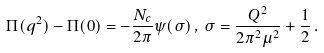<formula> <loc_0><loc_0><loc_500><loc_500>\Pi ( q ^ { 2 } ) - \Pi ( 0 ) = - \frac { N _ { c } } { 2 \pi } \psi ( \sigma ) \, , \, \sigma = \frac { Q ^ { 2 } } { 2 \pi ^ { 2 } \mu ^ { 2 } } + \frac { 1 } { 2 } \, .</formula> 